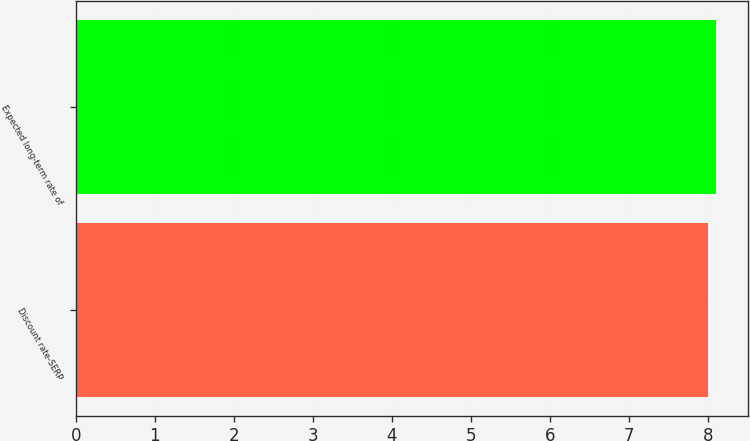<chart> <loc_0><loc_0><loc_500><loc_500><bar_chart><fcel>Discount rate-SERP<fcel>Expected long-term rate of<nl><fcel>8<fcel>8.1<nl></chart> 